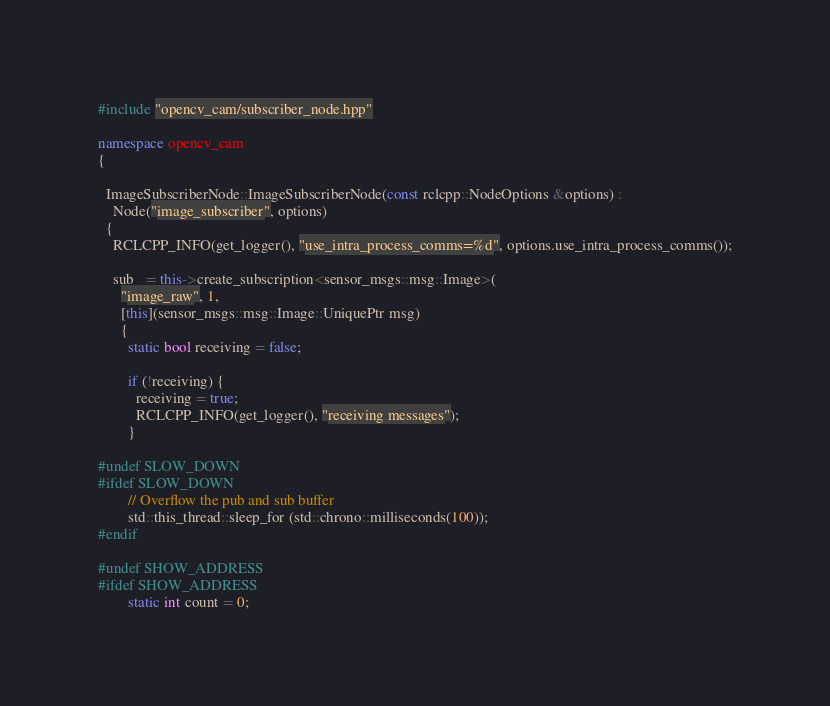<code> <loc_0><loc_0><loc_500><loc_500><_C++_>#include "opencv_cam/subscriber_node.hpp"

namespace opencv_cam
{

  ImageSubscriberNode::ImageSubscriberNode(const rclcpp::NodeOptions &options) :
    Node("image_subscriber", options)
  {
    RCLCPP_INFO(get_logger(), "use_intra_process_comms=%d", options.use_intra_process_comms());

    sub_ = this->create_subscription<sensor_msgs::msg::Image>(
      "image_raw", 1,
      [this](sensor_msgs::msg::Image::UniquePtr msg)
      {
        static bool receiving = false;

        if (!receiving) {
          receiving = true;
          RCLCPP_INFO(get_logger(), "receiving messages");
        }

#undef SLOW_DOWN
#ifdef SLOW_DOWN
        // Overflow the pub and sub buffer
        std::this_thread::sleep_for (std::chrono::milliseconds(100));
#endif

#undef SHOW_ADDRESS
#ifdef SHOW_ADDRESS
        static int count = 0;</code> 